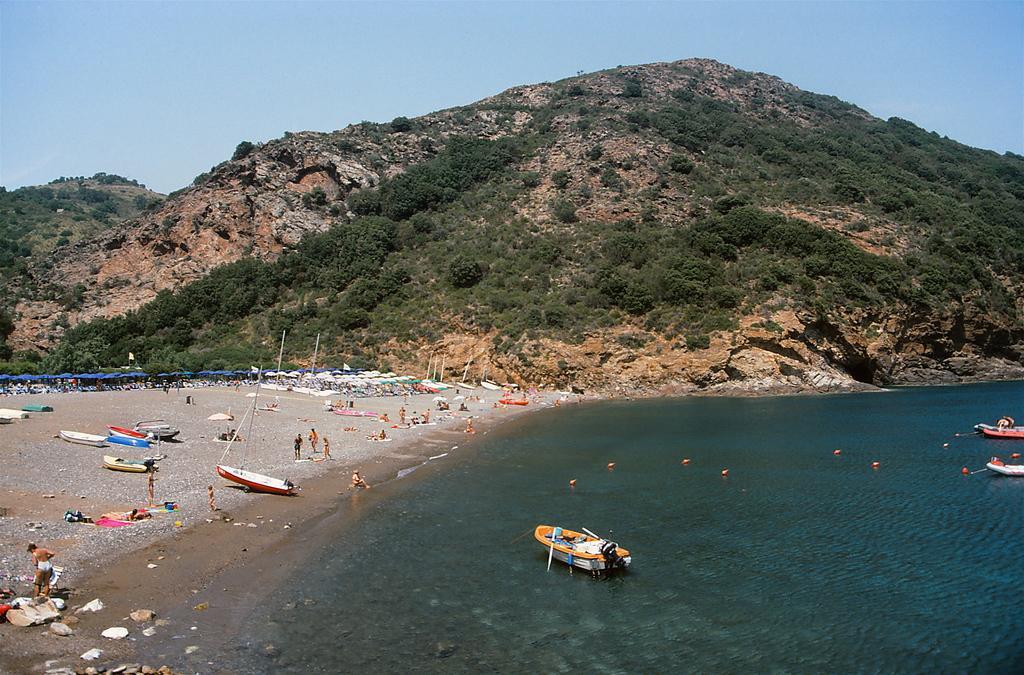In one or two sentences, can you explain what this image depicts? In this image we can see sky, hills, trees, ships in the sea, parasols and persons sitting and standing on the sea shore. 